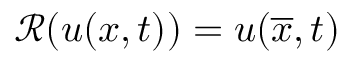<formula> <loc_0><loc_0><loc_500><loc_500>\ m a t h s c r { R } ( u ( x , t ) ) = u ( \overline { x } , t )</formula> 